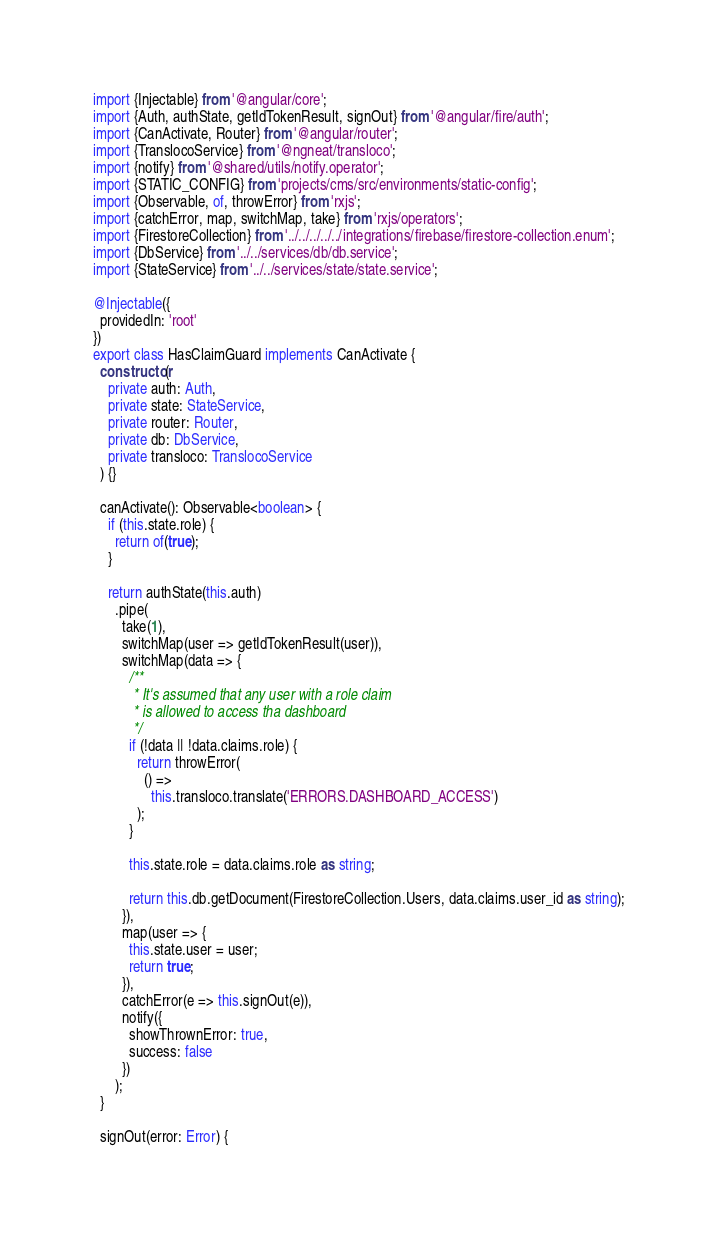Convert code to text. <code><loc_0><loc_0><loc_500><loc_500><_TypeScript_>import {Injectable} from '@angular/core';
import {Auth, authState, getIdTokenResult, signOut} from '@angular/fire/auth';
import {CanActivate, Router} from '@angular/router';
import {TranslocoService} from '@ngneat/transloco';
import {notify} from '@shared/utils/notify.operator';
import {STATIC_CONFIG} from 'projects/cms/src/environments/static-config';
import {Observable, of, throwError} from 'rxjs';
import {catchError, map, switchMap, take} from 'rxjs/operators';
import {FirestoreCollection} from '../../../../../integrations/firebase/firestore-collection.enum';
import {DbService} from '../../services/db/db.service';
import {StateService} from '../../services/state/state.service';

@Injectable({
  providedIn: 'root'
})
export class HasClaimGuard implements CanActivate {
  constructor(
    private auth: Auth,
    private state: StateService,
    private router: Router,
    private db: DbService,
    private transloco: TranslocoService
  ) {}

  canActivate(): Observable<boolean> {
    if (this.state.role) {
      return of(true);
    }

    return authState(this.auth)
      .pipe(
        take(1),
        switchMap(user => getIdTokenResult(user)),
        switchMap(data => {
          /**
           * It's assumed that any user with a role claim
           * is allowed to access tha dashboard
           */
          if (!data || !data.claims.role) {
            return throwError(
              () =>
                this.transloco.translate('ERRORS.DASHBOARD_ACCESS')
            );
          }

          this.state.role = data.claims.role as string;

          return this.db.getDocument(FirestoreCollection.Users, data.claims.user_id as string);
        }),
        map(user => {
          this.state.user = user;
          return true;
        }),
        catchError(e => this.signOut(e)),
        notify({
          showThrownError: true,
          success: false
        })
      );
  }

  signOut(error: Error) {</code> 